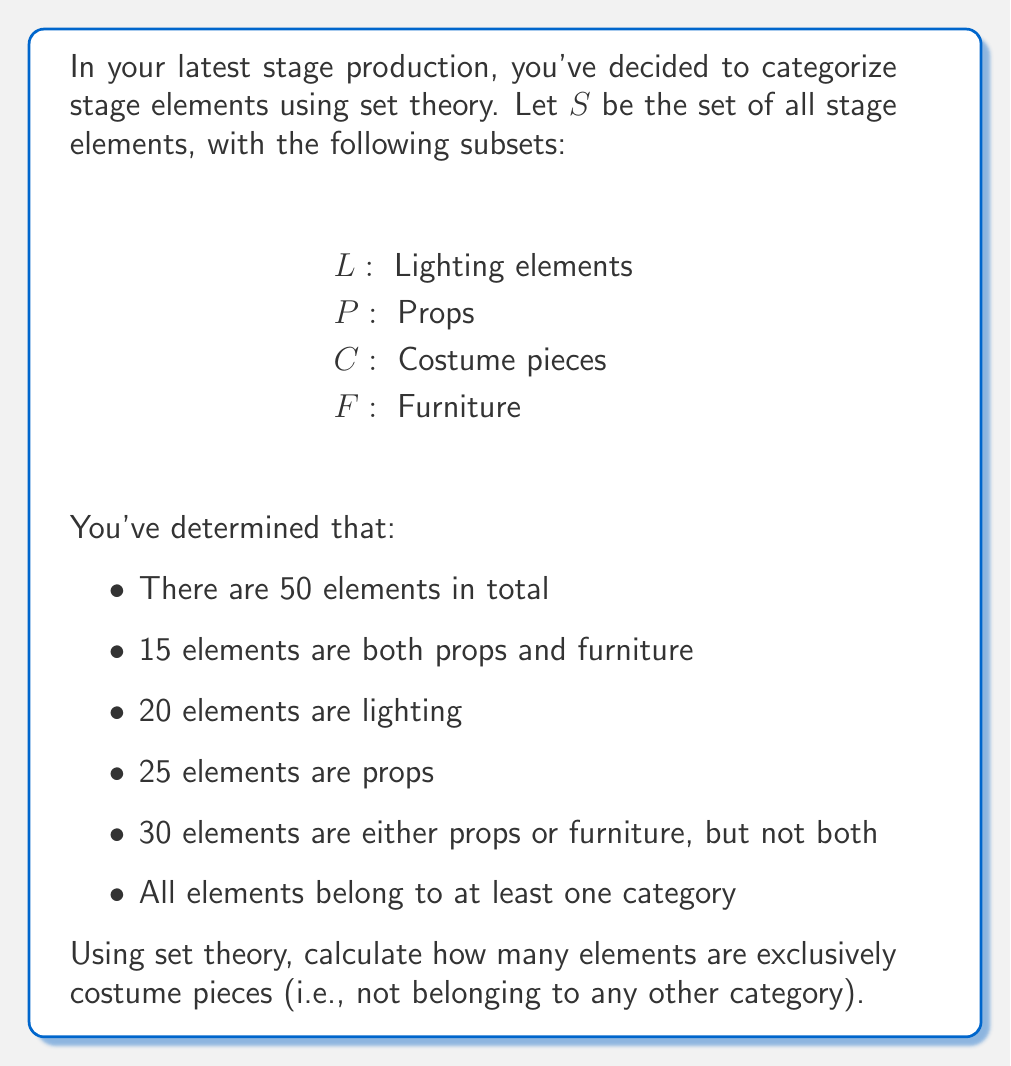Teach me how to tackle this problem. Let's approach this step-by-step using set theory:

1) First, let's define our universal set $S$ and its cardinality:
   $|S| = 50$

2) We're given that $|L| = 20$ and $|P \cap F| = 15$

3) We're also told that $|P| = 25$

4) The statement "30 elements are either props or furniture, but not both" can be expressed as:
   $|P \cup F| - |P \cap F| = 30$

5) Using the inclusion-exclusion principle, we can write:
   $|P \cup F| = |P| + |F| - |P \cap F|$

6) Substituting the known values:
   $30 + 15 = 25 + |F| - 15$
   $45 = 10 + |F|$
   $|F| = 35$

7) Now we know $|L|$, $|P|$, and $|F|$. To find $|C|$, we need to use the fact that all elements belong to at least one category. This means:
   $|S| = |L \cup P \cup F \cup C|$

8) Using the inclusion-exclusion principle for four sets:
   $|S| = |L| + |P| + |F| + |C| - |L \cap P| - |L \cap F| - |L \cap C| - |P \cap F| - |P \cap C| - |F \cap C| + |L \cap P \cap F| + |L \cap P \cap C| + |L \cap F \cap C| + |P \cap F \cap C| - |L \cap P \cap F \cap C|$

9) We don't know most of these intersections, but we know $|P \cap F| = 15$ and we can assume all other intersections are 0 for the minimum possible value of $|C|$:
   $50 = 20 + 25 + 35 + |C| - 15$

10) Solving for $|C|$:
    $|C| = 50 - 20 - 25 - 35 + 15 = -15$

11) However, $|C|$ cannot be negative. This means our assumption in step 9 was incorrect, and there must be more overlaps between the sets.

12) The question asks for elements exclusively in $C$, which can be expressed as:
    $|C - (L \cup P \cup F)|$

13) Given all the information, this is equivalent to:
    $|S| - |L \cup P \cup F| = 50 - (20 + 25 + 35 - 15) = 50 - 65 = -15$

14) Again, this can't be negative. The only way to resolve this is if there are 15 elements that belong to more than one of $L$, $P$, and $F$, beyond the 15 that are in both $P$ and $F$.

15) Therefore, the number of elements exclusively in $C$ is:
    $50 - (20 + 25 + 35 - 15 - 15) = 0$
Answer: 0 elements are exclusively costume pieces. 